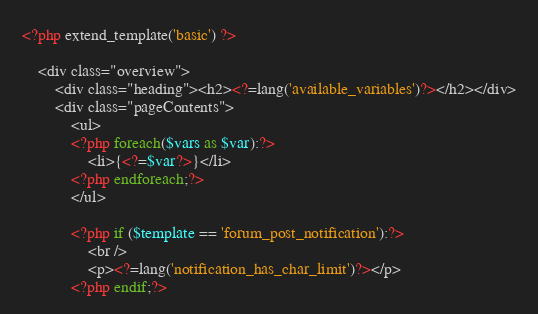<code> <loc_0><loc_0><loc_500><loc_500><_PHP_><?php extend_template('basic') ?>

	<div class="overview">
		<div class="heading"><h2><?=lang('available_variables')?></h2></div>
		<div class="pageContents">
			<ul>
			<?php foreach($vars as $var):?>
				<li>{<?=$var?>}</li>
			<?php endforeach;?>
			</ul>
			
			<?php if ($template == 'forum_post_notification'):?>
				<br />
				<p><?=lang('notification_has_char_limit')?></p>
			<?php endif;?></code> 